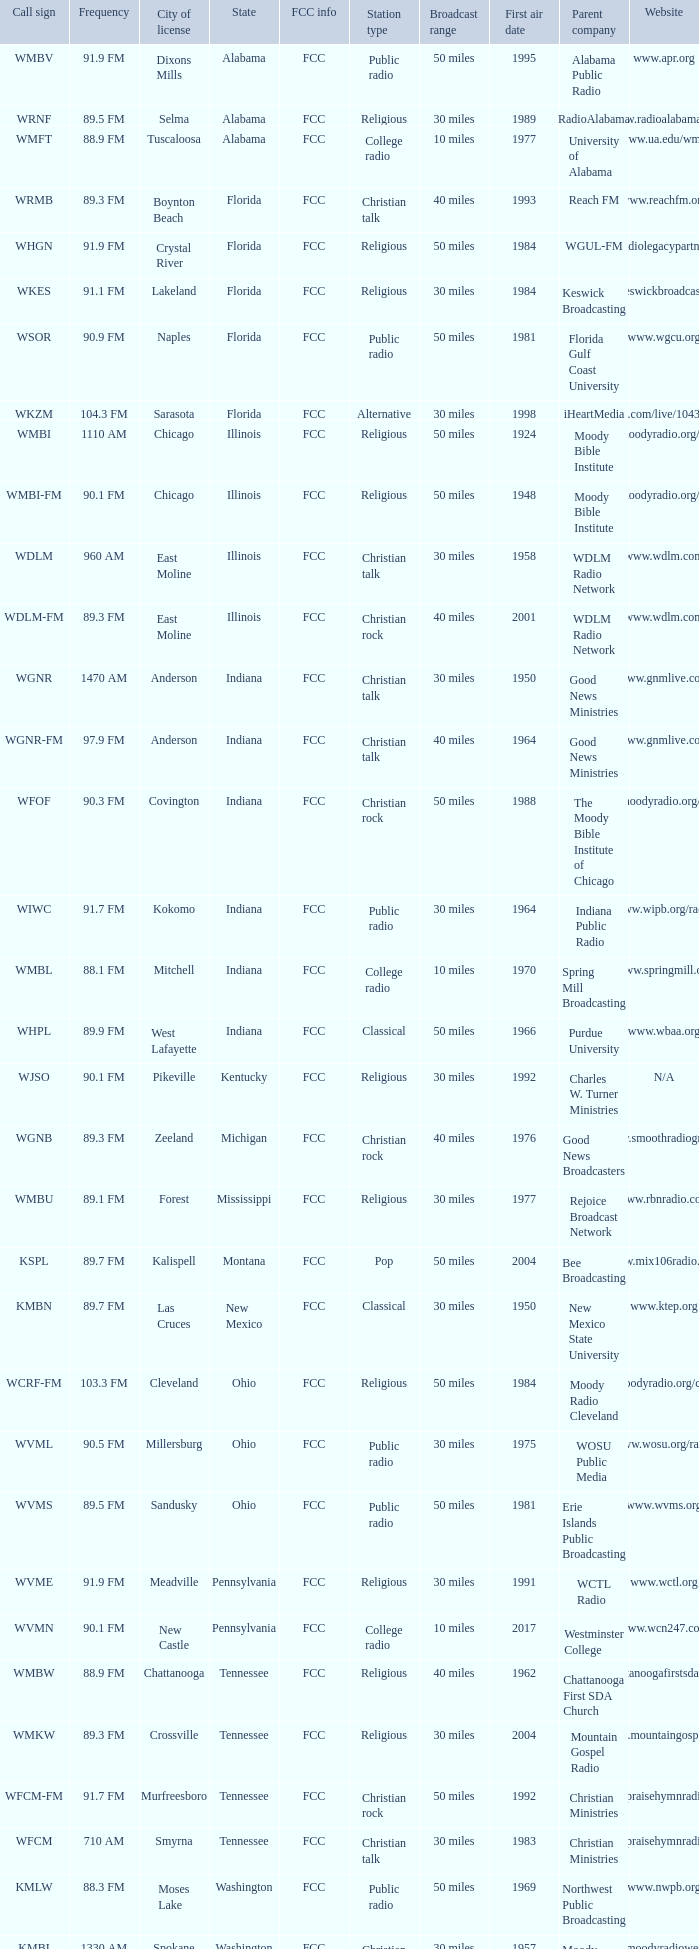What city is 103.3 FM licensed in? Cleveland. 